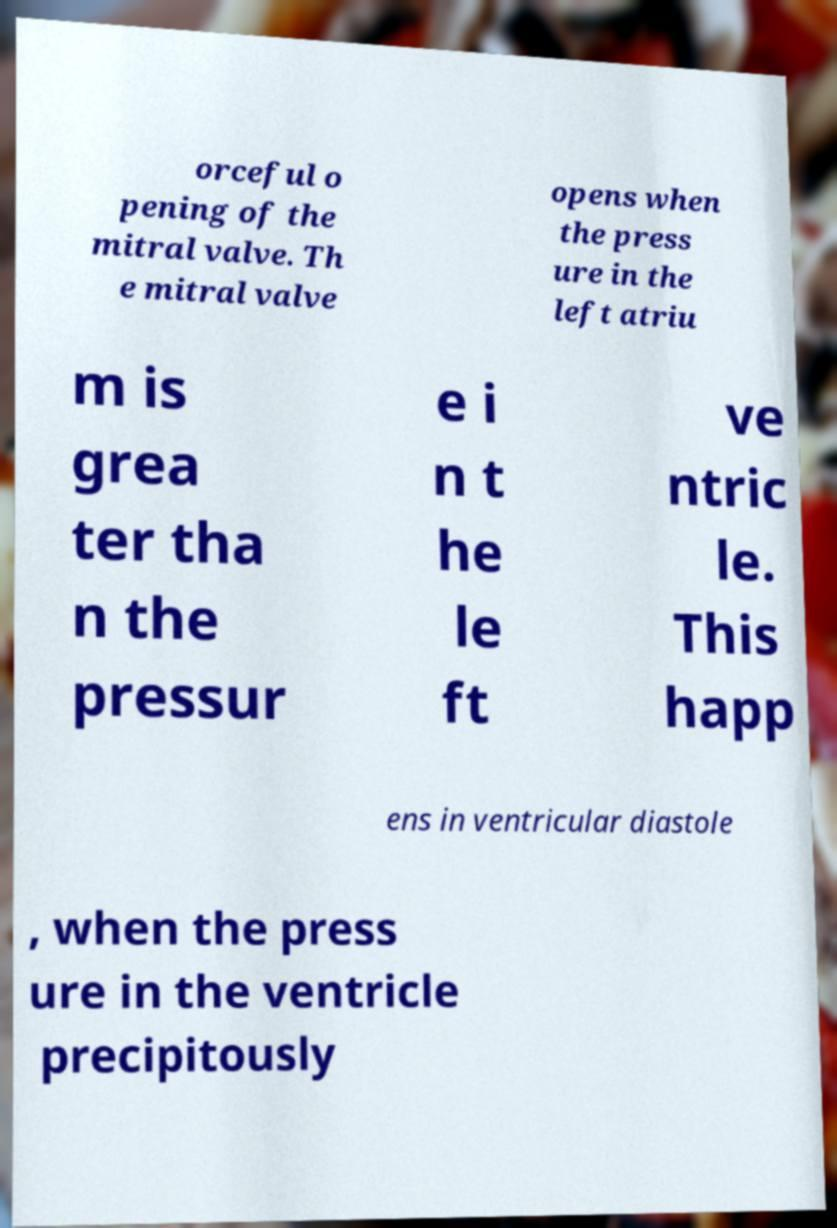What messages or text are displayed in this image? I need them in a readable, typed format. orceful o pening of the mitral valve. Th e mitral valve opens when the press ure in the left atriu m is grea ter tha n the pressur e i n t he le ft ve ntric le. This happ ens in ventricular diastole , when the press ure in the ventricle precipitously 